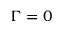Convert formula to latex. <formula><loc_0><loc_0><loc_500><loc_500>\Gamma = 0</formula> 